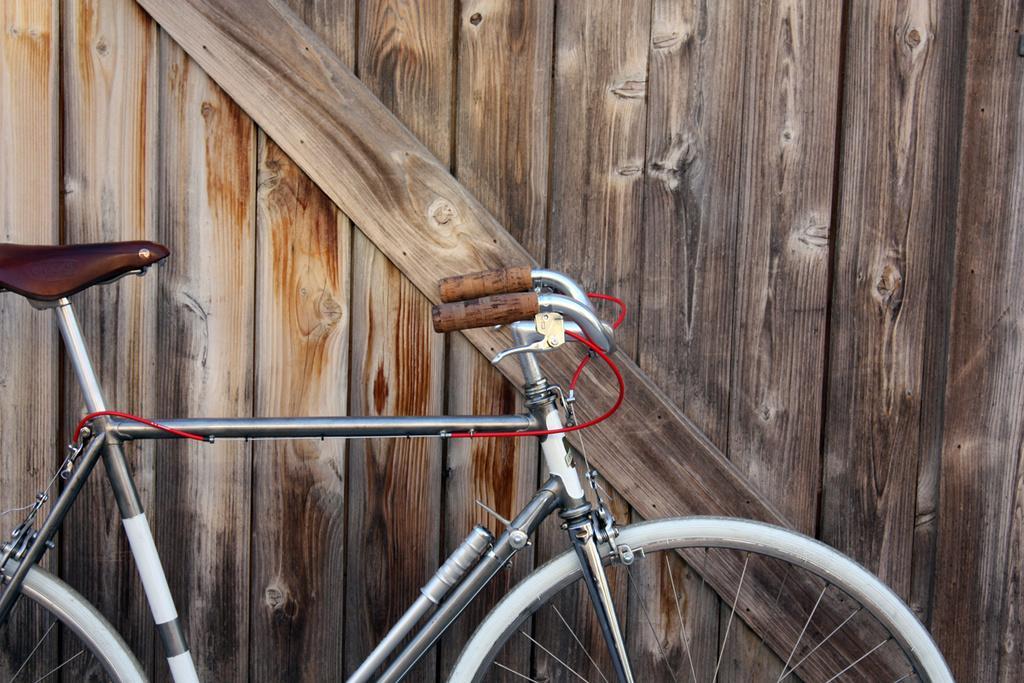Please provide a concise description of this image. In this picture we can see bicycle, behind this cycle we can see wooden wall. 